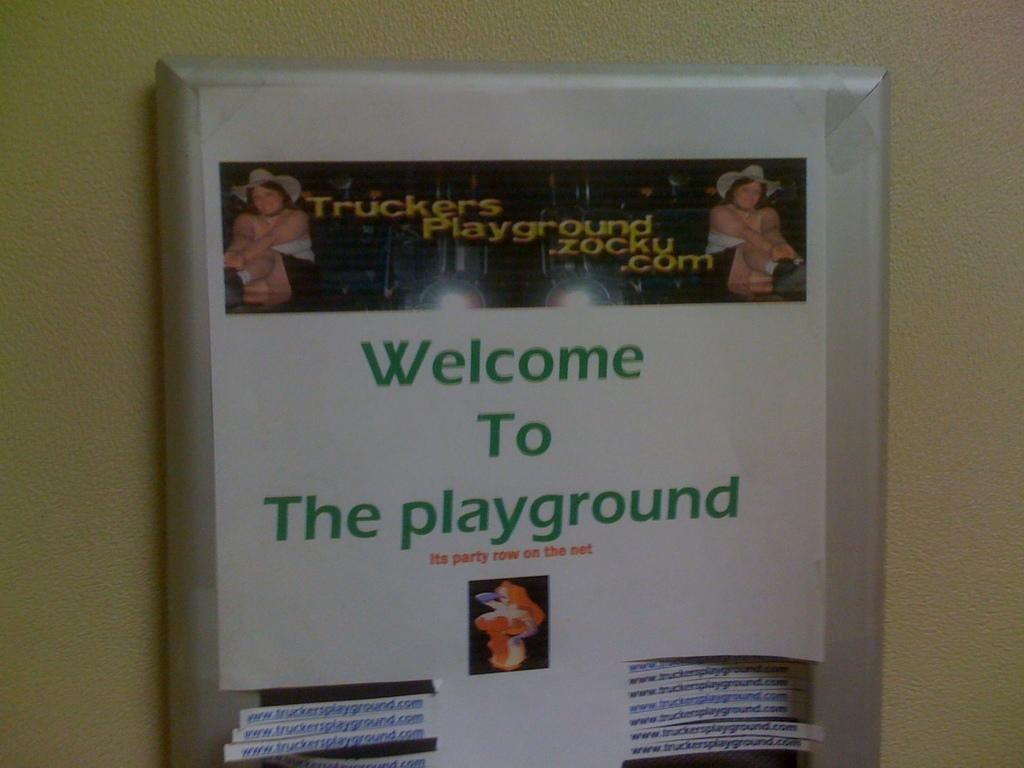<image>
Share a concise interpretation of the image provided. A sign which reads, "Welcome to The playground" is hanging on a wall. 